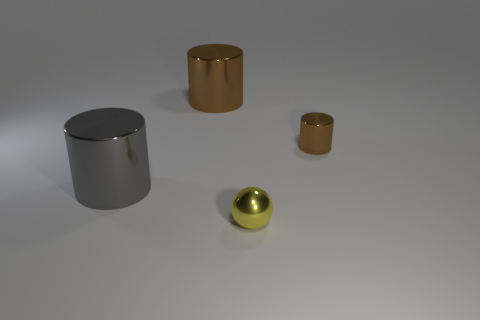What size is the brown cylinder that is to the right of the brown cylinder to the left of the ball?
Offer a very short reply. Small. The shiny thing that is the same color as the tiny cylinder is what size?
Your answer should be very brief. Large. How many other objects are the same size as the gray object?
Give a very brief answer. 1. What color is the tiny thing that is in front of the cylinder left of the brown shiny thing left of the tiny brown metal cylinder?
Offer a terse response. Yellow. What number of other things are there of the same shape as the yellow object?
Your response must be concise. 0. There is a tiny metal thing right of the tiny yellow object; what is its shape?
Give a very brief answer. Cylinder. Are there any small things left of the object on the right side of the metallic ball?
Your answer should be very brief. Yes. There is a metallic cylinder that is left of the tiny cylinder and behind the gray metallic cylinder; what is its color?
Offer a very short reply. Brown. Is there a tiny brown thing in front of the big cylinder that is behind the small metal object on the right side of the tiny metal ball?
Your answer should be compact. Yes. What size is the gray thing that is the same shape as the big brown metallic thing?
Give a very brief answer. Large. 